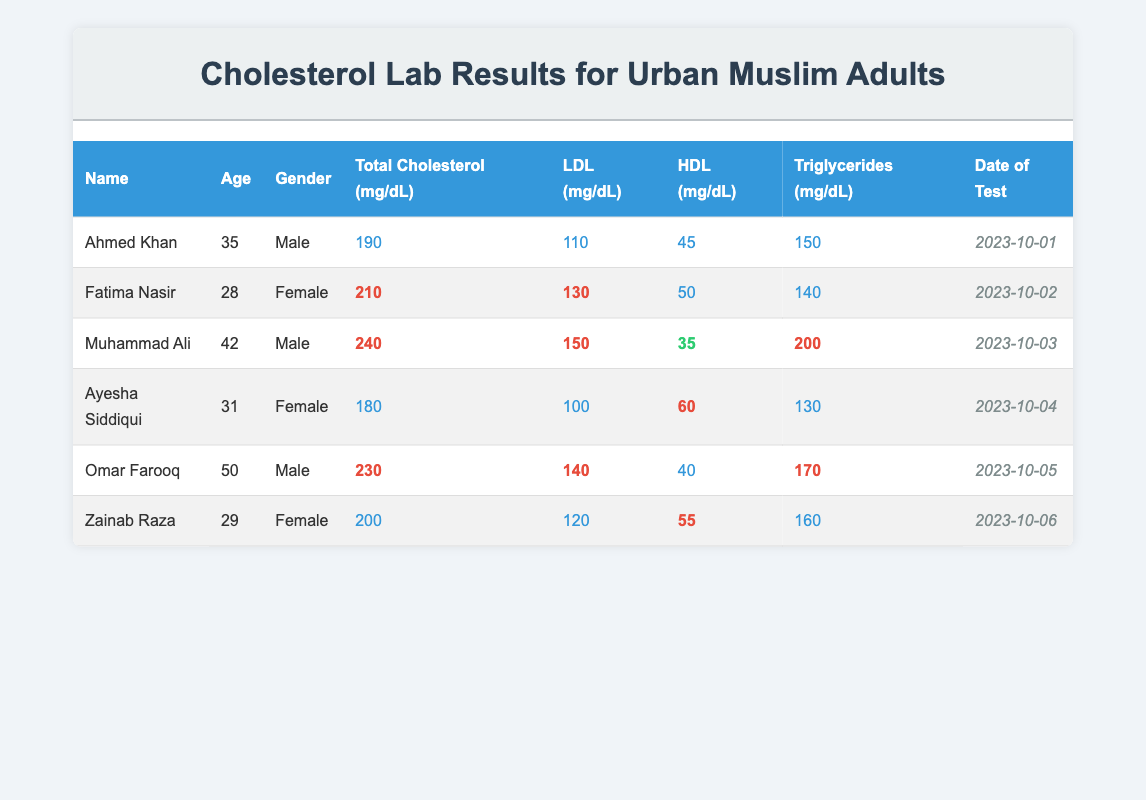What is the total cholesterol level of Fatima Nasir? The table lists Fatima Nasir's total cholesterol level under the "Total Cholesterol (mg/dL)" column, which shows a value of 210.
Answer: 210 Who has the highest level of LDL cholesterol in the table? Looking through the "LDL (mg/dL)" column, we see that Muhammad Ali has the highest LDL level at 150 mg/dL.
Answer: Muhammad Ali What is the average age of the individuals tested? To find the average age, add up the ages (35 + 28 + 42 + 31 + 50 + 29 = 215) and divide by the number of individuals (6). The average is 215 / 6 = 35.83 years, approximately 36 years.
Answer: 36 Is Ayesha Siddiqui's HDL level normal? Ayesha Siddiqui's HDL level is 60 mg/dL, which is generally considered a good level for HDL cholesterol, thus indicating it is normal.
Answer: Yes What is the difference between the total cholesterol levels of Ahmed Khan and Omar Farooq? Ahmed Khan has a total cholesterol level of 190 mg/dL and Omar Farooq has a level of 230 mg/dL. The difference is 230 - 190 = 40 mg/dL.
Answer: 40 Are there any individuals with high triglycerides levels (greater than 150 mg/dL)? By examining the "Triglycerides (mg/dL)" column, we find that Muhammad Ali (200), Omar Farooq (170), and Zainab Raza (160) have levels greater than 150. Therefore, yes, there are individuals with high triglycerides.
Answer: Yes What is the total number of individuals with high total cholesterol (greater than 200 mg/dL)? Referencing the "Total Cholesterol (mg/dL)" column, Fatima Nasir (210), Muhammad Ali (240), and Omar Farooq (230) have levels greater than 200 mg/dL. This amounts to 3 individuals.
Answer: 3 Which female has the highest HDL level and what is that level? Looking at the "HDL (mg/dL)" column, Ayesha Siddiqui has the highest HDL level at 60 mg/dL compared to Fatima Nasir (50) and Zainab Raza (55).
Answer: Ayesha Siddiqui, 60 What percentage of the individuals tested are male? There are 3 male individuals (Ahmed Khan, Muhammad Ali, and Omar Farooq) out of a total of 6 individuals. The percentage is (3/6) * 100 = 50%.
Answer: 50 